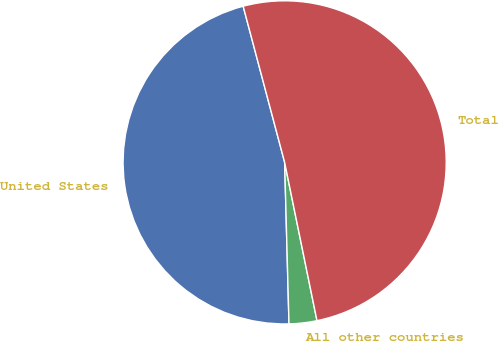Convert chart. <chart><loc_0><loc_0><loc_500><loc_500><pie_chart><fcel>United States<fcel>All other countries<fcel>Total<nl><fcel>46.29%<fcel>2.78%<fcel>50.92%<nl></chart> 